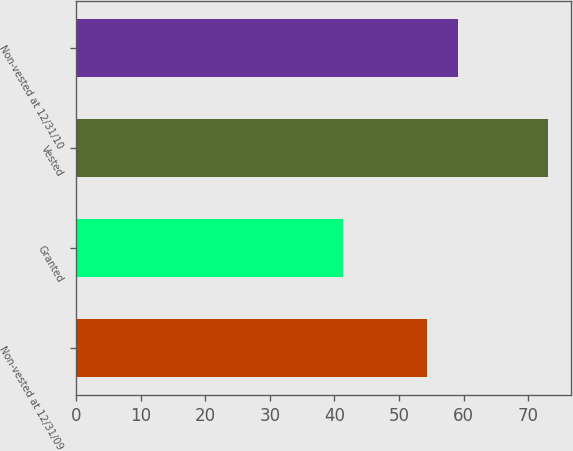<chart> <loc_0><loc_0><loc_500><loc_500><bar_chart><fcel>Non-vested at 12/31/09<fcel>Granted<fcel>Vested<fcel>Non-vested at 12/31/10<nl><fcel>54.32<fcel>41.34<fcel>73.03<fcel>59.1<nl></chart> 